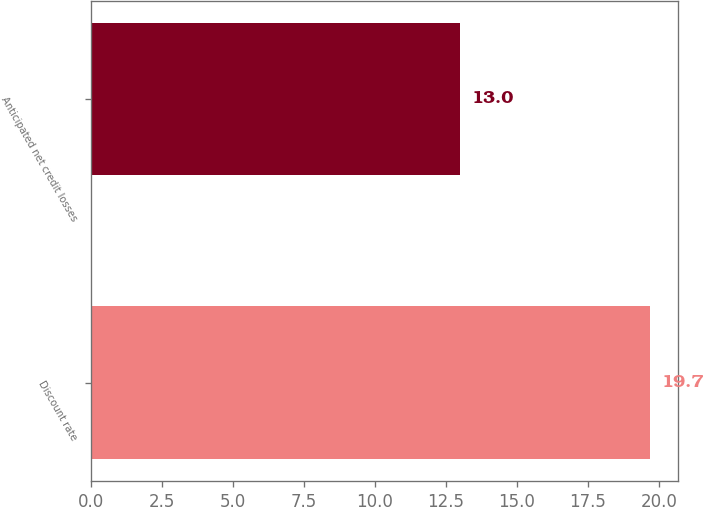Convert chart to OTSL. <chart><loc_0><loc_0><loc_500><loc_500><bar_chart><fcel>Discount rate<fcel>Anticipated net credit losses<nl><fcel>19.7<fcel>13<nl></chart> 